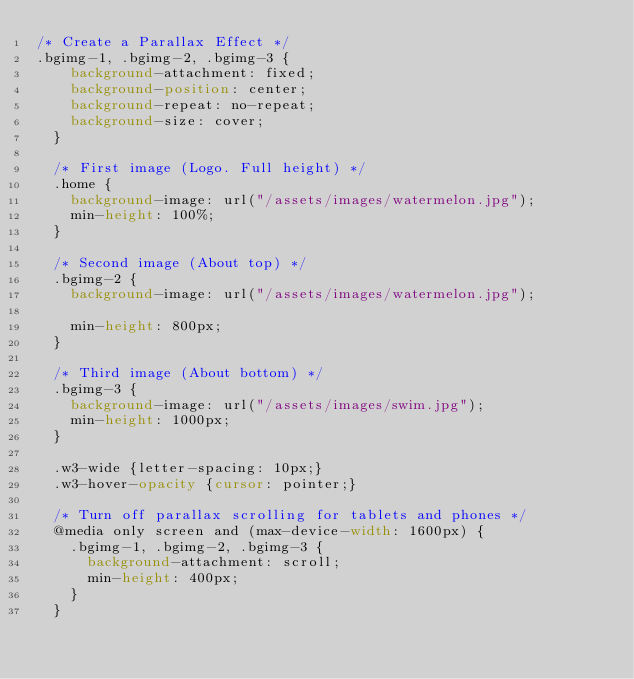Convert code to text. <code><loc_0><loc_0><loc_500><loc_500><_CSS_>/* Create a Parallax Effect */
.bgimg-1, .bgimg-2, .bgimg-3 {
    background-attachment: fixed;
    background-position: center;
    background-repeat: no-repeat;
    background-size: cover;
  }
  
  /* First image (Logo. Full height) */
  .home {
    background-image: url("/assets/images/watermelon.jpg");
    min-height: 100%;
  }
  
  /* Second image (About top) */
  .bgimg-2 {
    background-image: url("/assets/images/watermelon.jpg");

    min-height: 800px;
  }
  
  /* Third image (About bottom) */
  .bgimg-3 {
    background-image: url("/assets/images/swim.jpg");
    min-height: 1000px;
  }
  
  .w3-wide {letter-spacing: 10px;}
  .w3-hover-opacity {cursor: pointer;}
  
  /* Turn off parallax scrolling for tablets and phones */
  @media only screen and (max-device-width: 1600px) {
    .bgimg-1, .bgimg-2, .bgimg-3 {
      background-attachment: scroll;
      min-height: 400px;
    }
  }</code> 